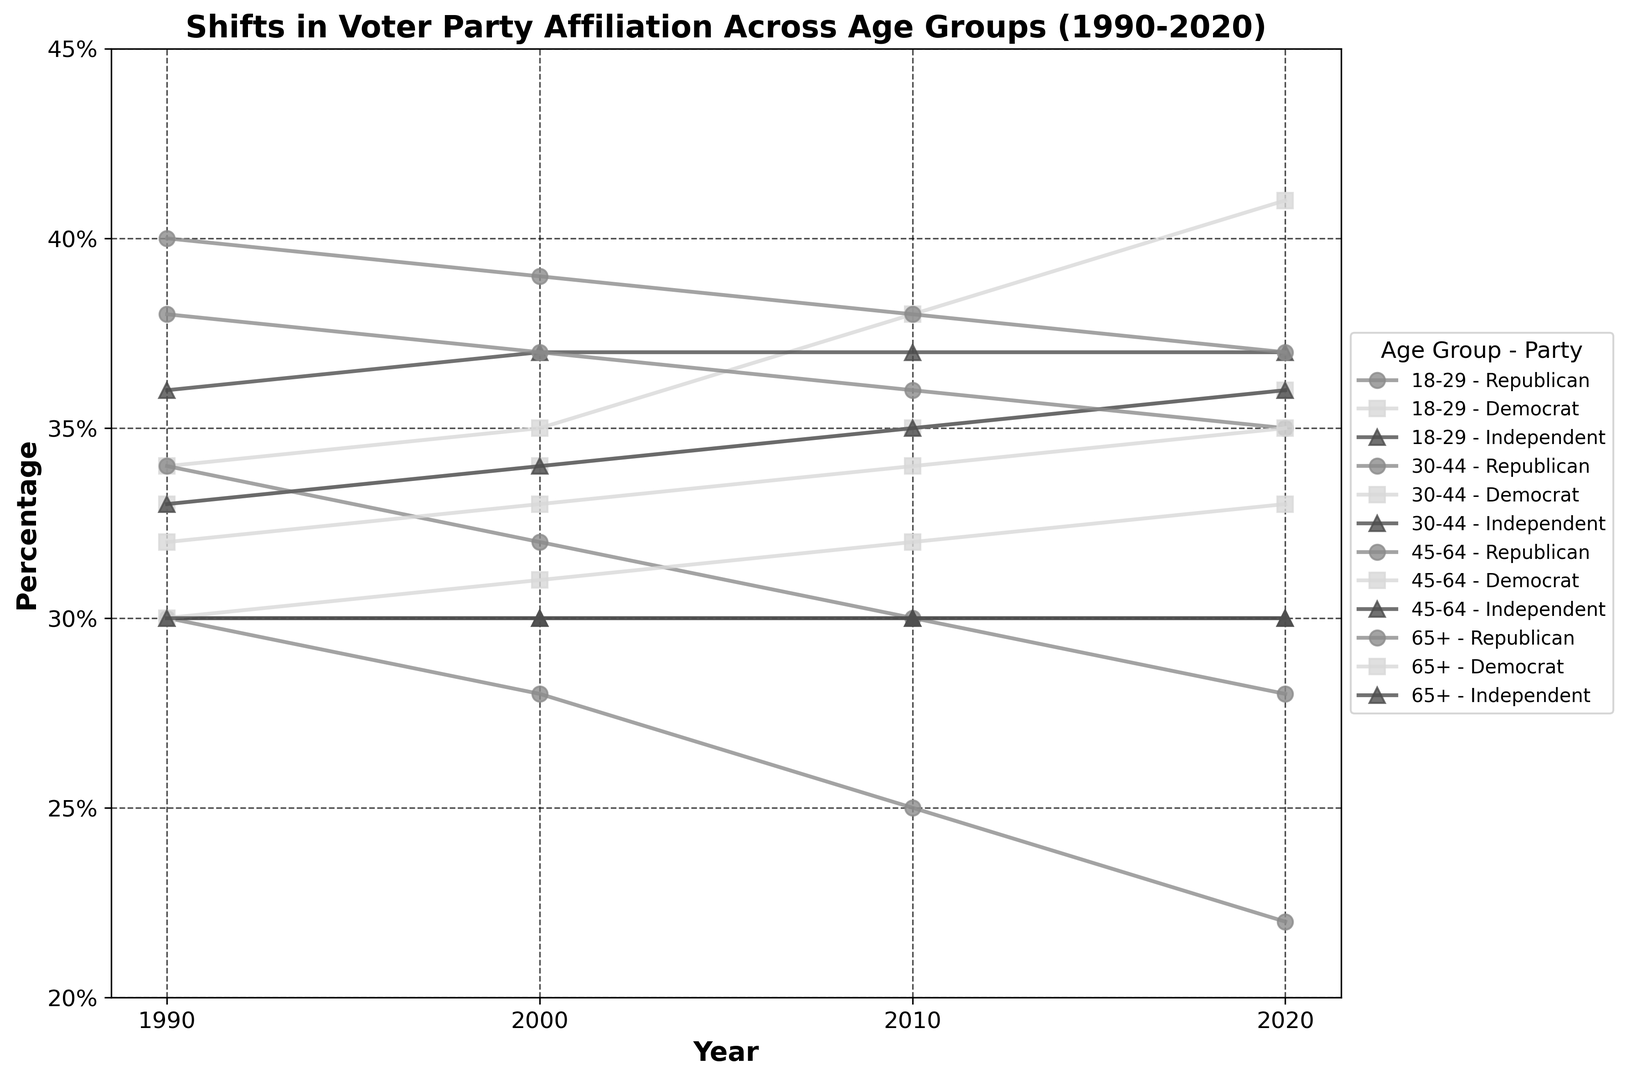What is the trend in Republican affiliation among the 18-29 age group over the last 30 years? The percentage of Republican affiliation in the 18-29 age group has decreased steadily over the years. Starting from 30% in 1990, it dropped to 28% in 2000, 25% in 2010, and 22% in 2020.
Answer: A steady decline Which age group showed the largest increase in Democrat affiliation from 1990 to 2020? By comparing the increase in Democrat affiliation across all age groups, we see that the 18-29 age group showed an increase from 34% in 1990 to 41% in 2020, which is an increase of 7%.
Answer: 18-29 How did the percentage of Independent voters change for the 30-44 age group from 2000 to 2020? The percentage of Independent voters in the 30-44 age group increased from 34% in 2000 to 36% in 2020, which is an increase of 2%.
Answer: Increased by 2% Which age group had the highest percentage of Republican affiliation in 2020, and what was the percentage? In 2020, the age group 65+ had the highest Republican affiliation percentage of 37%. The data for other groups are 22% for 18-29, 28% for 30-44, and 35% for 45-64.
Answer: 65+ with 37% What was the difference in Democrat affiliation between the 18-29 age group and the 65+ age group in 2020? In 2020, the Democrat affiliation for the 18-29 age group was 41%, and for the 65+ age group, it was 33%. The difference is 41% - 33% = 8%.
Answer: 8% What's the average percentage of Independent voters across all age groups in 2020? To find the average percentage of Independent voters in 2020, sum the percentages (37% for 18-29, 36% for 30-44, 30% for 45-64, 30% for 65+) and divide by 4. The total is 133%, so the average is 133% / 4 = 33.25%.
Answer: 33.25% Which party affiliation remained most stable in the 45-64 age group from 1990 to 2020? Observing the 45-64 age group data: Republican affiliation slowly decreased from 38% to 35%, Democrat affiliation increased from 32% to 35%, and Independent affiliation remained constant at 30%. Independent affiliation, thus, remained the most stable.
Answer: Independent For which party did the 30-44 age group see the smallest change in affiliation from 1990 to 2020? Between 1990 and 2020, the 30-44 age group saw the percentages for Republicans decline by 6% (from 34% to 28%), Democrats rise by 3% (from 33% to 36%), and Independents increase by 3% (from 33% to 36%). The Democratic and Independent changes are smallest, both at 3%.
Answer: Democrat and Independent What is the percentage difference between Republican affiliation for the 65+ age group and the 18-29 age group in 1990? In 1990, Republican affiliation was 40% for the 65+ age group and 30% for the 18-29 age group. The percentage difference is 40% - 30% = 10%.
Answer: 10% 